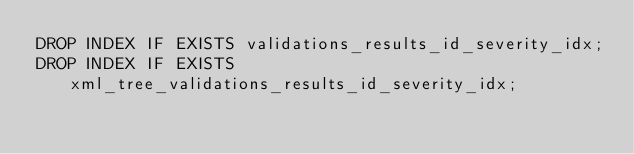<code> <loc_0><loc_0><loc_500><loc_500><_SQL_>DROP INDEX IF EXISTS validations_results_id_severity_idx;
DROP INDEX IF EXISTS xml_tree_validations_results_id_severity_idx;
</code> 